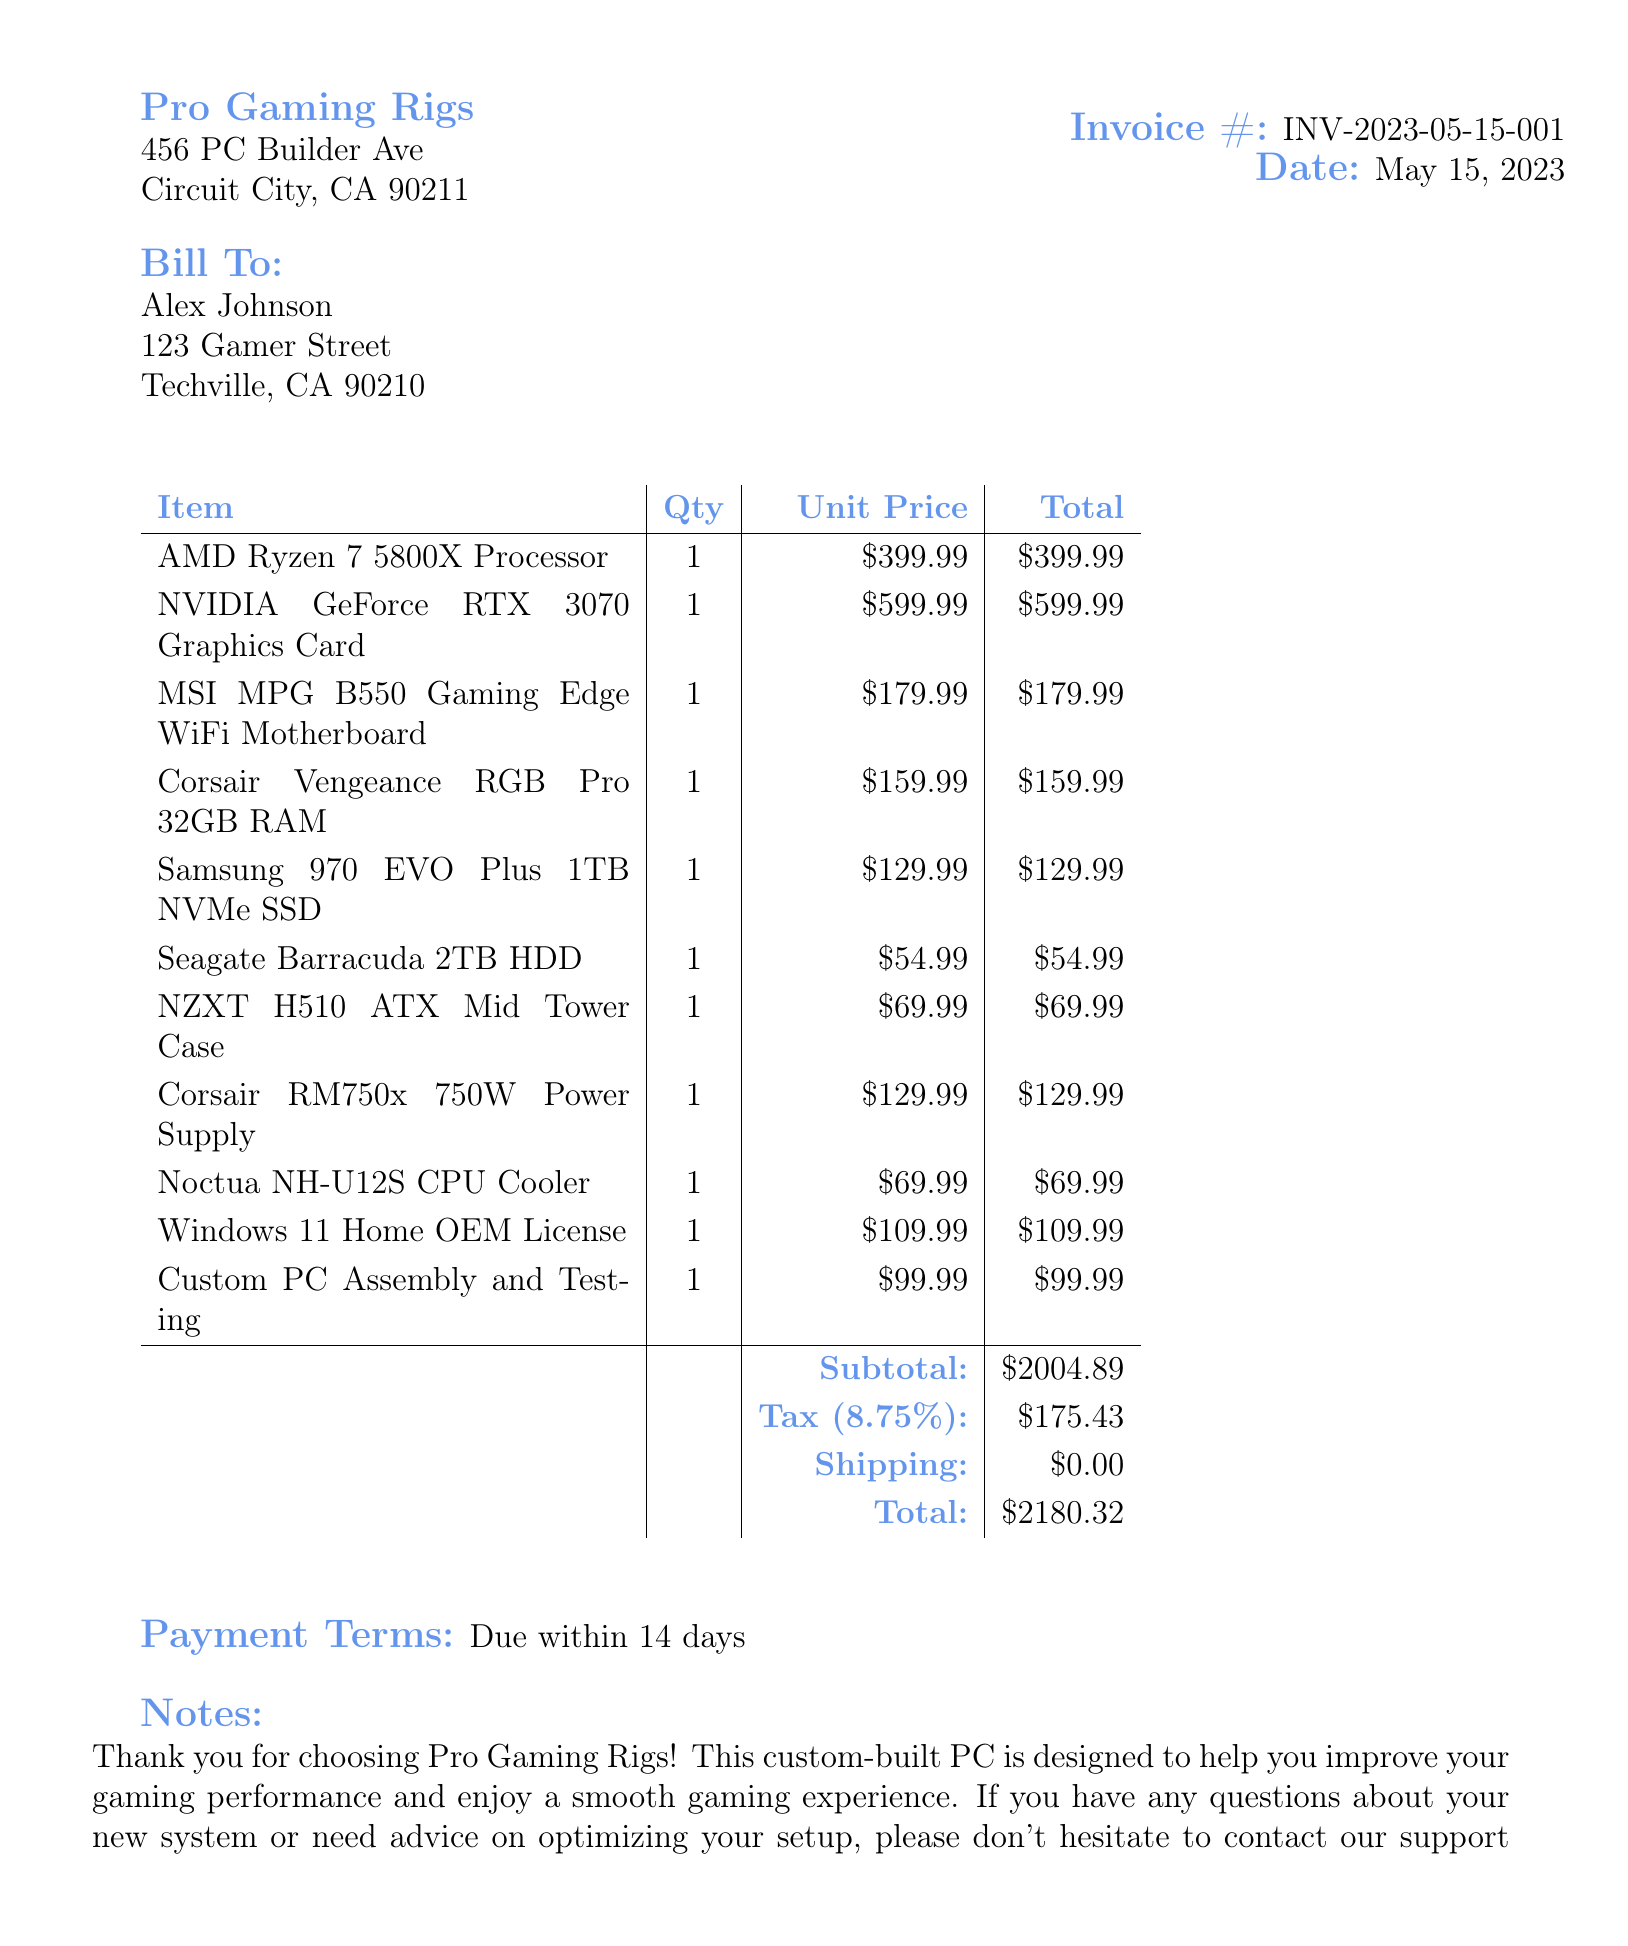What is the invoice number? The invoice number can be found in the header section of the document, specifically labeled as "Invoice #."
Answer: INV-2023-05-15-001 What is the date of the invoice? The date of the invoice is listed in the header section alongside the invoice number.
Answer: May 15, 2023 Who is the customer? The customer's name is indicated in the "Bill To" section of the invoice.
Answer: Alex Johnson What is the total amount due? The total amount is calculated at the end of the invoice, summarizing all costs, taxes, and shipping.
Answer: $2180.32 What was the quantity of the NVIDIA GeForce RTX 3070 Graphics Card? The quantity is shown in the itemized list of products and their costs.
Answer: 1 What is included in the "Notes" section? The notes section of the invoice provides additional information or messages to the customer, typically added at the end of the document.
Answer: Thank you for choosing Pro Gaming Rigs! This custom-built PC is designed to help you improve your gaming performance and enjoy a smooth gaming experience. If you have any questions about your new system or need advice on optimizing your setup, please don't hesitate to contact our support team What is the tax rate applied? The tax rate can be found in the detailed cost breakdown that specifies the percentage applied to the subtotal.
Answer: 8.75% What is the payment term mentioned? The payment terms are provided clearly at the bottom of the invoice, indicating the timeframe for payment.
Answer: Due within 14 days What service was charged for Custom PC Assembly? This refers to a specific service included in the invoice to ensure the PC is built and tested professionally.
Answer: Professional build and quality assurance 